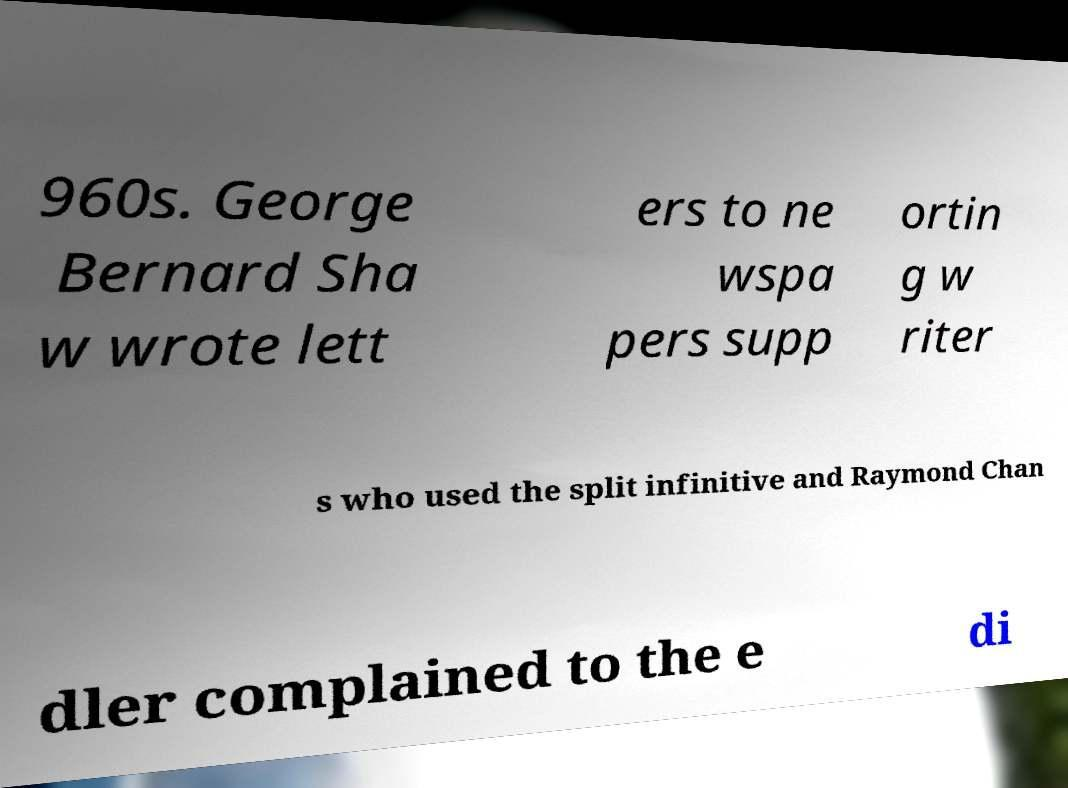Please identify and transcribe the text found in this image. 960s. George Bernard Sha w wrote lett ers to ne wspa pers supp ortin g w riter s who used the split infinitive and Raymond Chan dler complained to the e di 